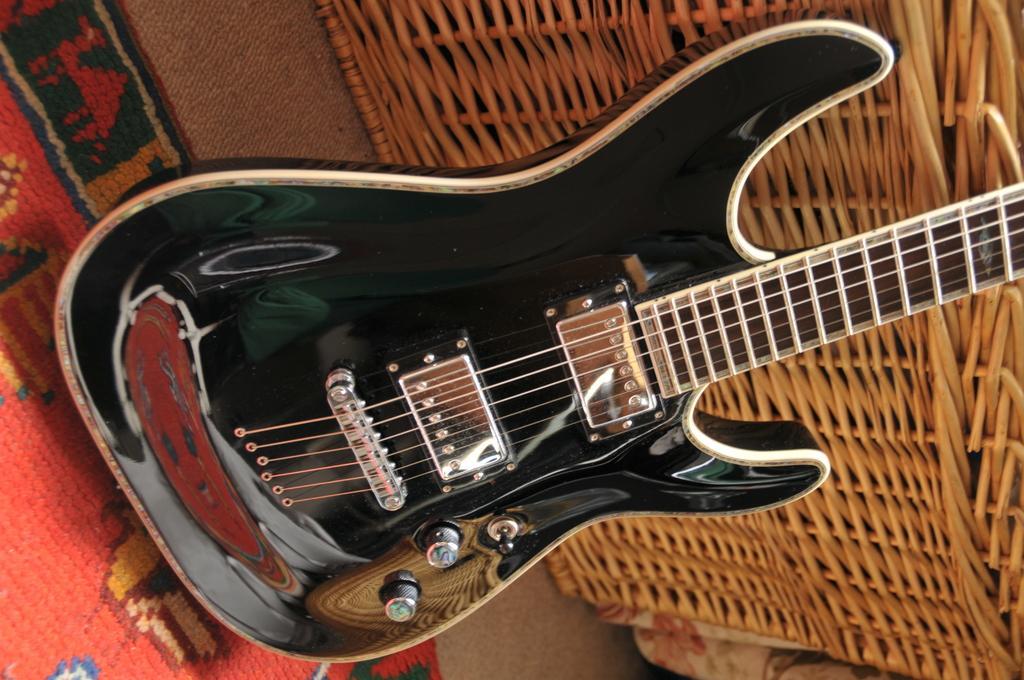Please provide a concise description of this image. In front of the image there is a guitar on the mat. Beside the guitar there are some objects. 